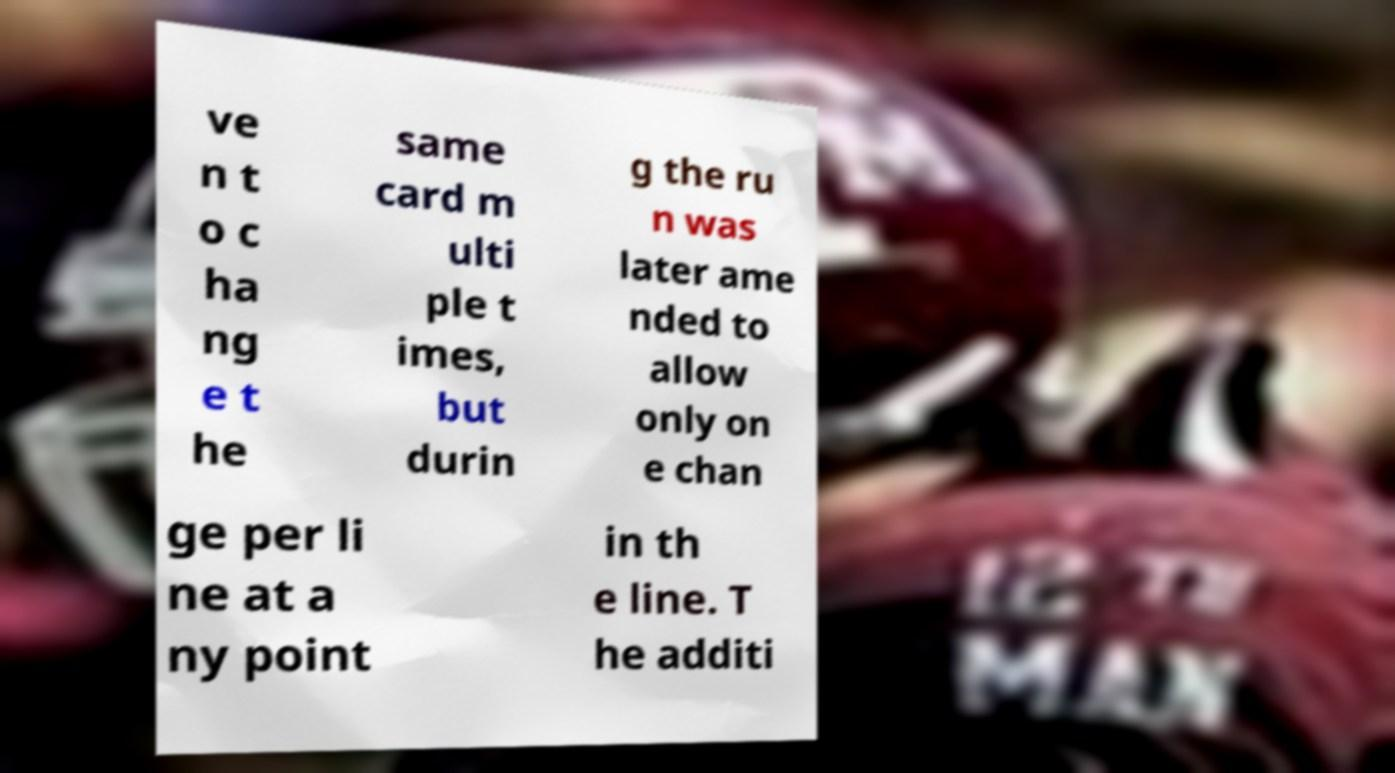Could you extract and type out the text from this image? ve n t o c ha ng e t he same card m ulti ple t imes, but durin g the ru n was later ame nded to allow only on e chan ge per li ne at a ny point in th e line. T he additi 